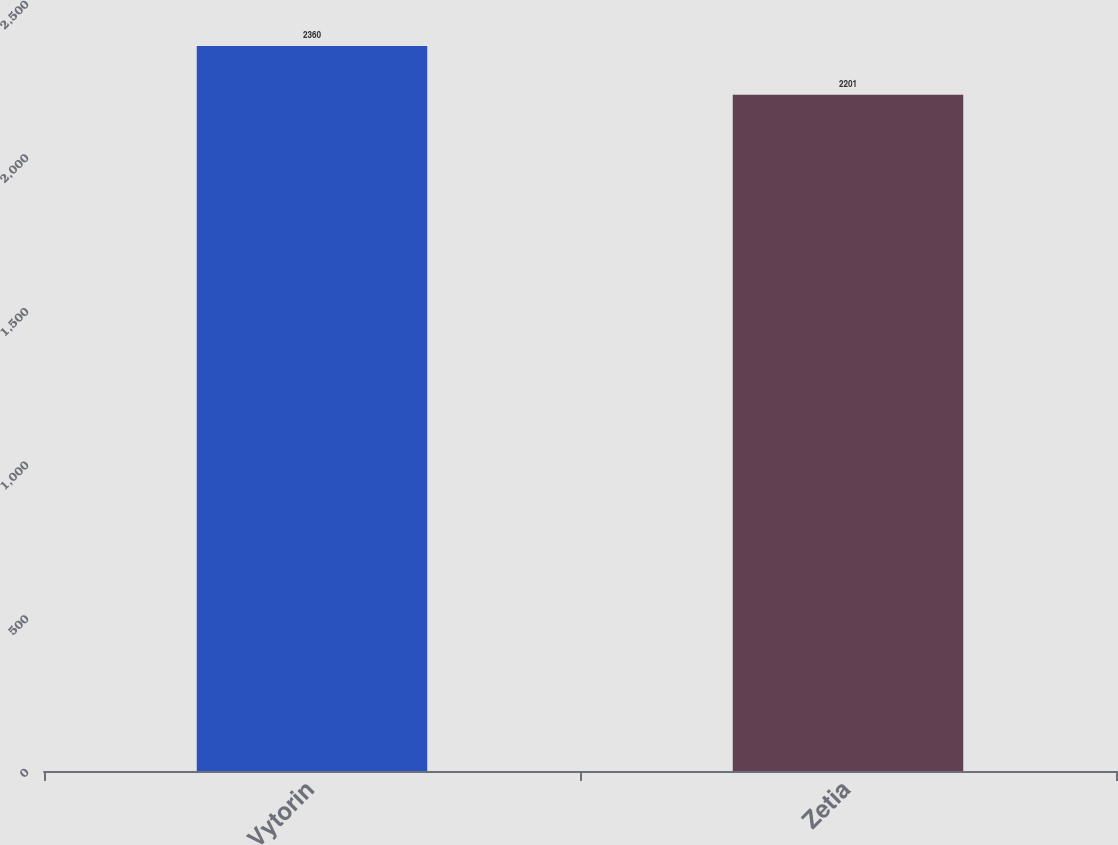<chart> <loc_0><loc_0><loc_500><loc_500><bar_chart><fcel>Vytorin<fcel>Zetia<nl><fcel>2360<fcel>2201<nl></chart> 